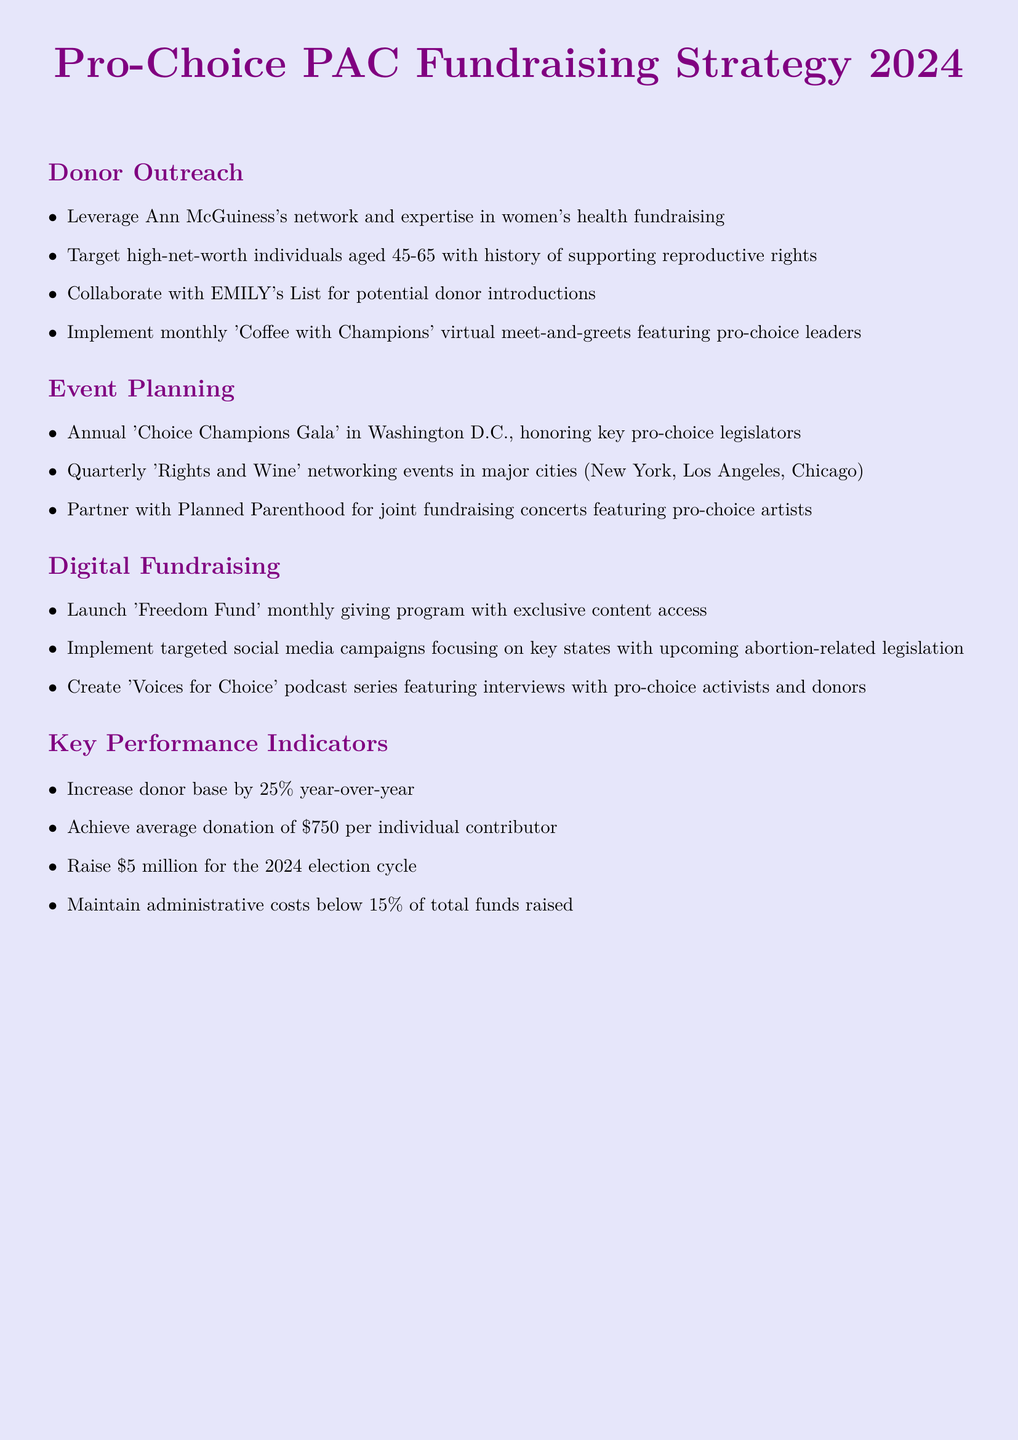What is the title of the document? The title of the document is presented at the top of the document.
Answer: Pro-Choice PAC Fundraising Strategy 2024 What monthly program is being launched? The monthly program is mentioned under the Digital Fundraising section.
Answer: Freedom Fund What is the goal for increasing the donor base? The goal for increasing the donor base is stated in the Key Performance Indicators section.
Answer: 25% Which city is the 'Choice Champions Gala' held in? The location of the annual gala is specified in the Event Planning section.
Answer: Washington D.C What type of events are the 'Rights and Wine'? The nature of these events is specified under the Event Planning section.
Answer: Networking events Who is suggested to collaborate with for donor introductions? The collaboration suggestion is mentioned in the Donor Outreach section.
Answer: EMILY's List What is the average donation goal per individual contributor? The average donation goal is stated in the Key Performance Indicators section.
Answer: 750 What is the total fundraising goal for the 2024 election cycle? The total fundraising goal is explicitly mentioned in the Key Performance Indicators section.
Answer: 5 million 